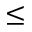<formula> <loc_0><loc_0><loc_500><loc_500>\leq</formula> 